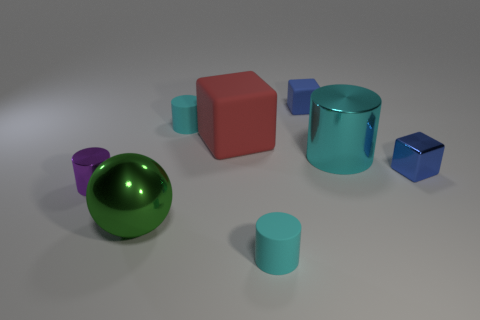Add 1 tiny brown metallic blocks. How many objects exist? 9 Subtract all cyan cylinders. How many cylinders are left? 1 Subtract 0 green cylinders. How many objects are left? 8 Subtract all spheres. How many objects are left? 7 Subtract 1 cubes. How many cubes are left? 2 Subtract all brown spheres. Subtract all green cubes. How many spheres are left? 1 Subtract all purple blocks. How many purple cylinders are left? 1 Subtract all green balls. Subtract all small purple shiny things. How many objects are left? 6 Add 8 big green objects. How many big green objects are left? 9 Add 3 blocks. How many blocks exist? 6 